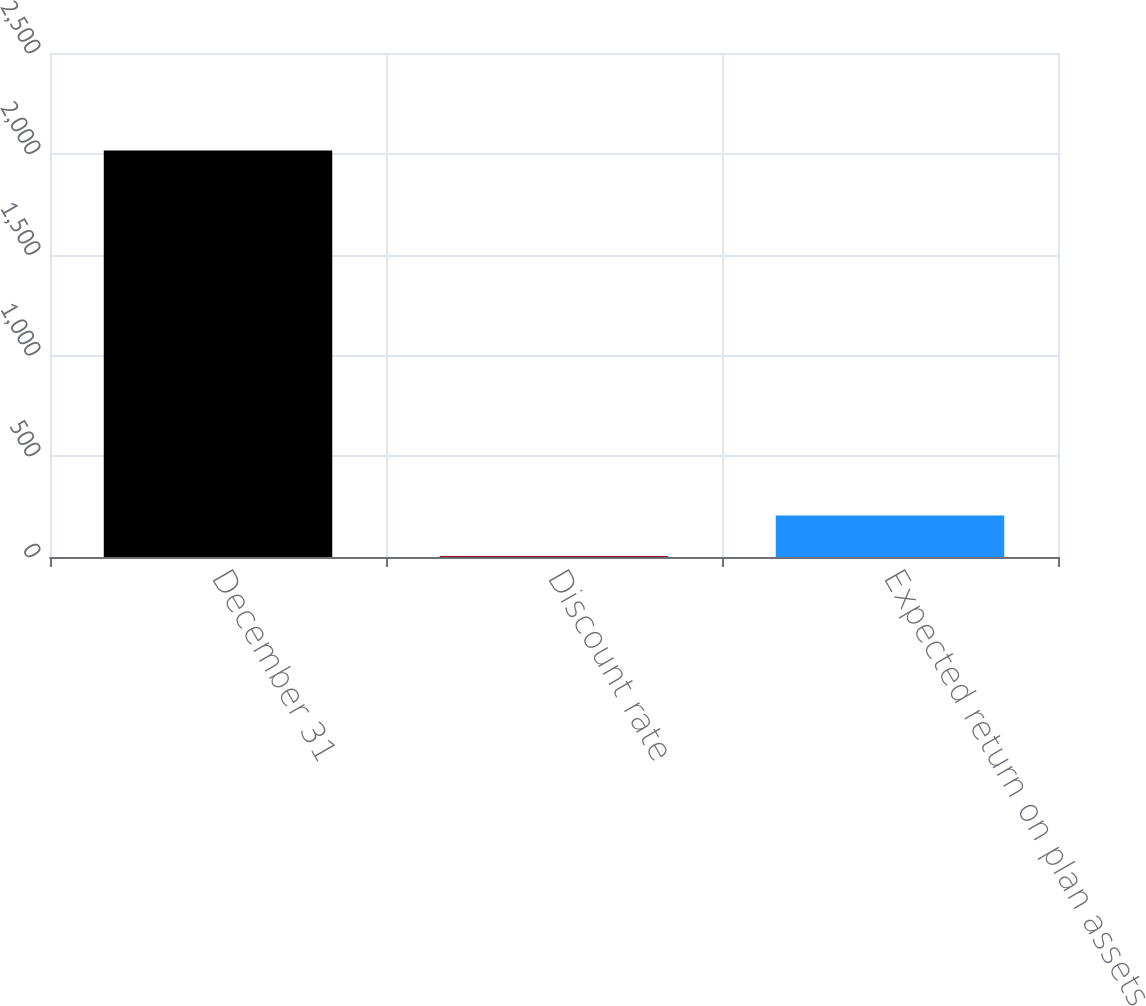Convert chart to OTSL. <chart><loc_0><loc_0><loc_500><loc_500><bar_chart><fcel>December 31<fcel>Discount rate<fcel>Expected return on plan assets<nl><fcel>2016<fcel>4.45<fcel>205.6<nl></chart> 